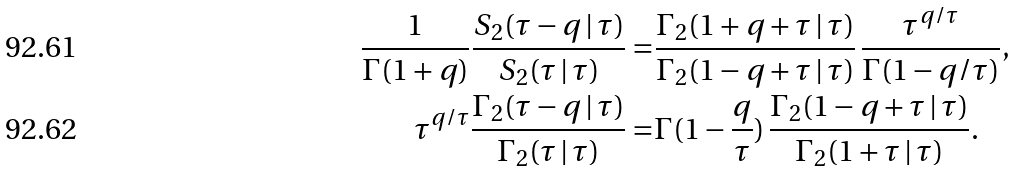Convert formula to latex. <formula><loc_0><loc_0><loc_500><loc_500>\frac { 1 } { \Gamma ( 1 + q ) } \frac { S _ { 2 } ( \tau - q \, | \, \tau ) } { S _ { 2 } ( \tau \, | \, \tau ) } = & \frac { \Gamma _ { 2 } ( 1 + q + \tau \, | \, \tau ) } { \Gamma _ { 2 } ( 1 - q + \tau \, | \, \tau ) } \, \frac { \tau ^ { q / \tau } } { \Gamma ( 1 - q / \tau ) } , \\ \tau ^ { q / \tau } \frac { \Gamma _ { 2 } ( \tau - q \, | \, \tau ) } { \Gamma _ { 2 } ( \tau \, | \, \tau ) } = & \Gamma ( 1 - \frac { q } { \tau } ) \, \frac { \Gamma _ { 2 } ( 1 - q + \tau \, | \, \tau ) } { \Gamma _ { 2 } ( 1 + \tau \, | \, \tau ) } .</formula> 